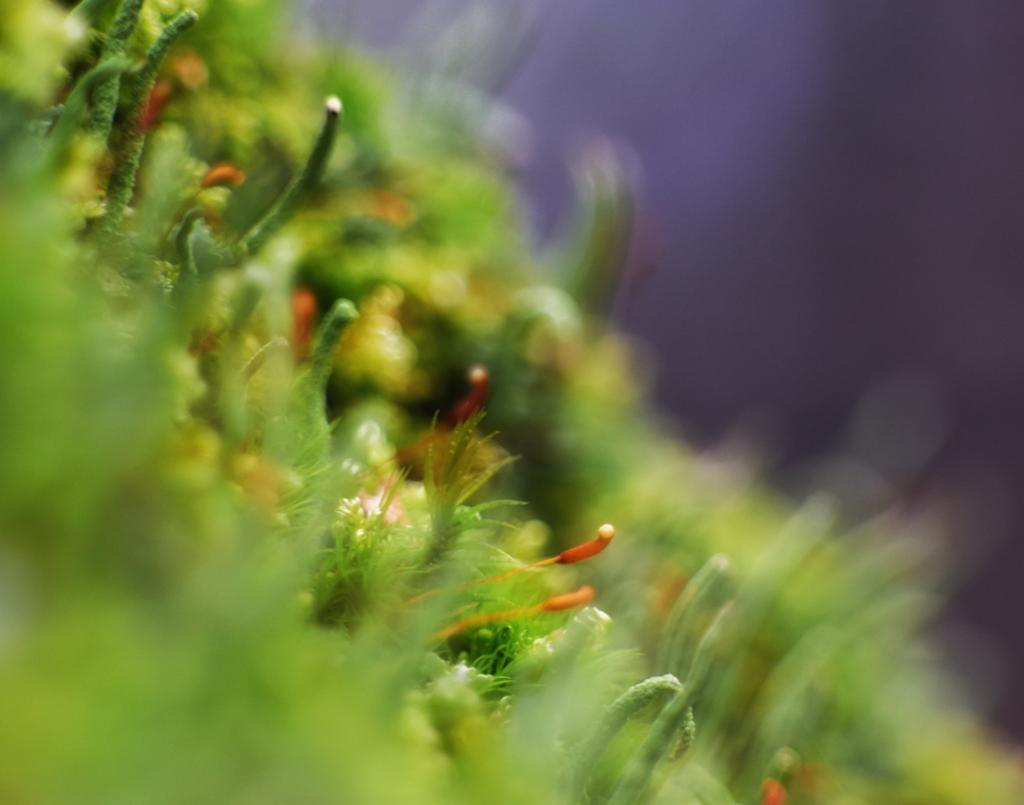What is the overall quality of the image? The image is blurry. What type of environment or setting can be seen in the image? There is greenery visible in the image. What type of sheet is being used to cover the hat in the image? There is no sheet or hat present in the image; it only features greenery. 